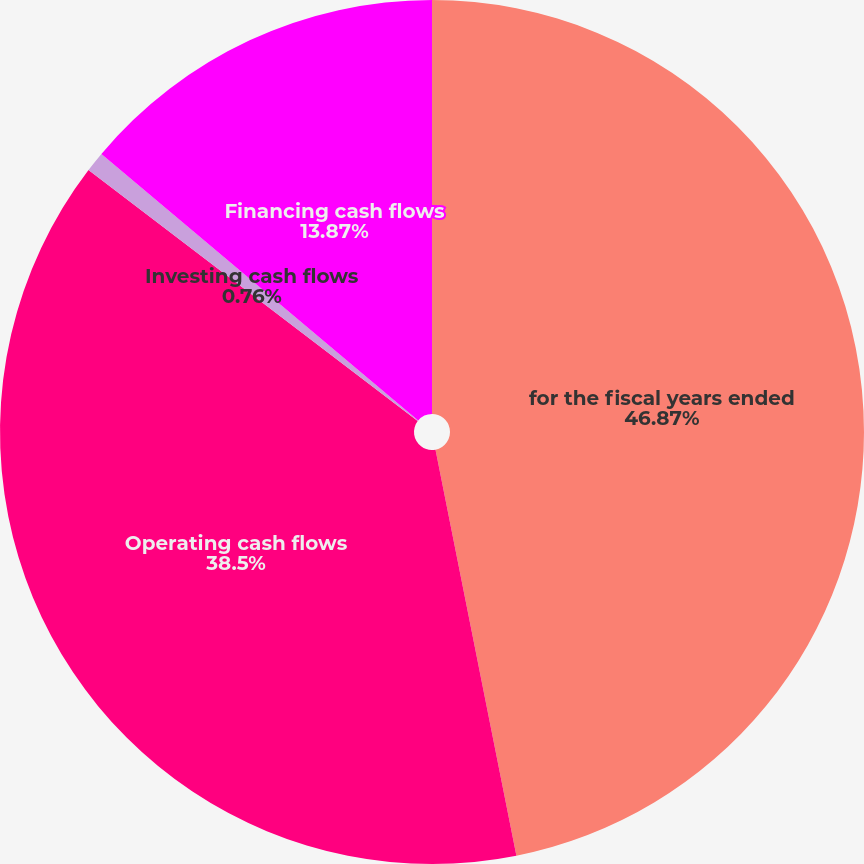Convert chart. <chart><loc_0><loc_0><loc_500><loc_500><pie_chart><fcel>for the fiscal years ended<fcel>Operating cash flows<fcel>Investing cash flows<fcel>Financing cash flows<nl><fcel>46.87%<fcel>38.5%<fcel>0.76%<fcel>13.87%<nl></chart> 